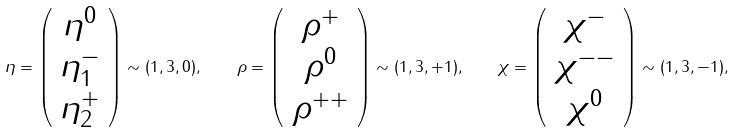<formula> <loc_0><loc_0><loc_500><loc_500>\eta = \left ( \begin{array} { c } \eta ^ { 0 } \\ \eta ^ { - } _ { 1 } \\ \eta ^ { + } _ { 2 } \end{array} \right ) \sim ( { 1 } , { 3 } , 0 ) , \quad \rho = \left ( \begin{array} { c } \rho ^ { + } \\ \rho ^ { 0 } \\ \rho ^ { + + } \end{array} \right ) \sim ( { 1 } , { 3 } , + 1 ) , \quad \chi = \left ( \begin{array} { c } \chi ^ { - } \\ \chi ^ { - - } \\ \chi ^ { 0 } \end{array} \right ) \sim ( { 1 } , { 3 } , - 1 ) ,</formula> 